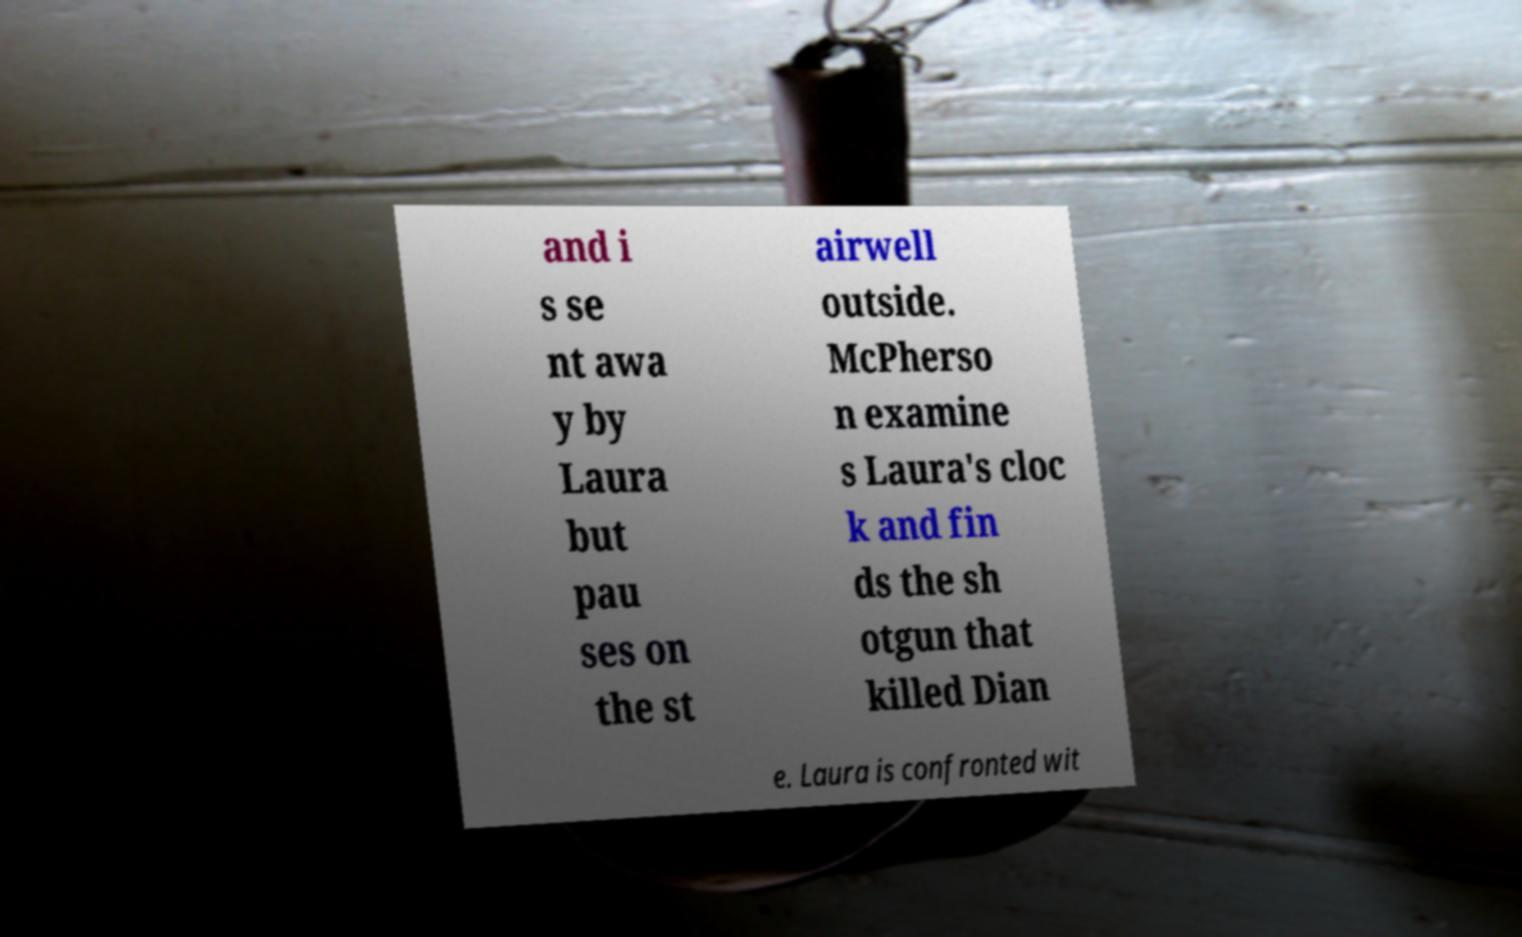Please read and relay the text visible in this image. What does it say? and i s se nt awa y by Laura but pau ses on the st airwell outside. McPherso n examine s Laura's cloc k and fin ds the sh otgun that killed Dian e. Laura is confronted wit 